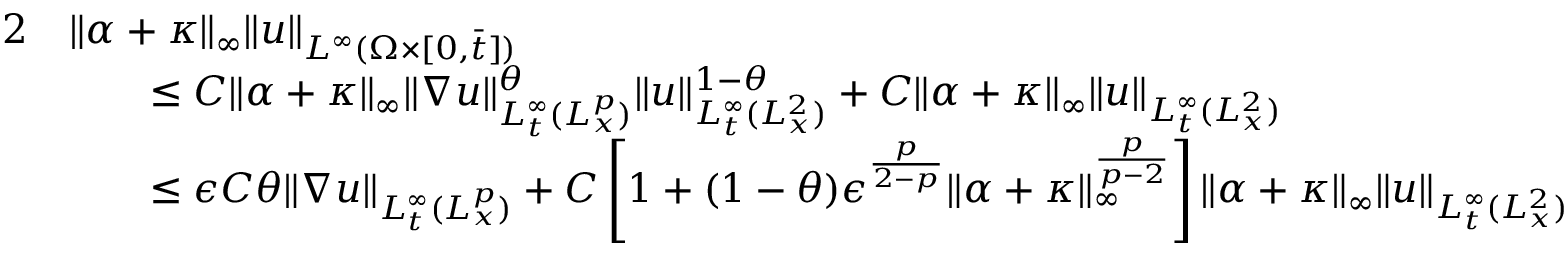Convert formula to latex. <formula><loc_0><loc_0><loc_500><loc_500>\begin{array} { r l } { 2 } & { \| \alpha + \kappa \| _ { \infty } \| u \| _ { L ^ { \infty } ( \Omega \times [ 0 , \bar { t } ] ) } } \\ & { \quad \leq C \| \alpha + \kappa \| _ { \infty } \| \nabla u \| _ { L _ { t } ^ { \infty } ( L _ { x } ^ { p } ) } ^ { \theta } \| u \| _ { L _ { t } ^ { \infty } ( L _ { x } ^ { 2 } ) } ^ { 1 - \theta } + C \| \alpha + \kappa \| _ { \infty } \| u \| _ { L _ { t } ^ { \infty } ( L _ { x } ^ { 2 } ) } } \\ & { \quad \leq \epsilon C \theta \| \nabla u \| _ { L _ { t } ^ { \infty } ( L _ { x } ^ { p } ) } + C \left [ 1 + ( 1 - \theta ) \epsilon ^ { \frac { p } { 2 - p } } \| \alpha + \kappa \| _ { \infty } ^ { \frac { p } { p - 2 } } \right ] \| \alpha + \kappa \| _ { \infty } \| u \| _ { L _ { t } ^ { \infty } ( L _ { x } ^ { 2 } ) } } \end{array}</formula> 